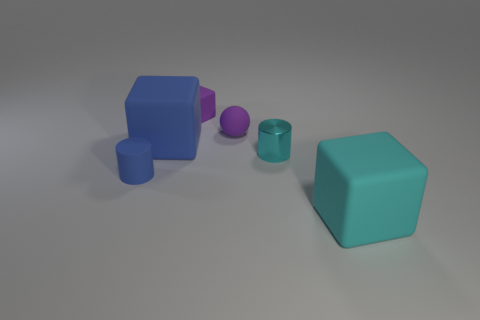There is a tiny matte thing that is the same shape as the big blue thing; what color is it?
Provide a short and direct response. Purple. Does the big matte cube in front of the tiny cyan thing have the same color as the small matte cylinder?
Offer a very short reply. No. How many small blue metal objects are there?
Keep it short and to the point. 0. Are the big block to the left of the cyan block and the purple sphere made of the same material?
Offer a terse response. Yes. Is there any other thing that has the same material as the cyan cylinder?
Make the answer very short. No. How many small blue cylinders are right of the cube that is in front of the small cylinder behind the tiny blue rubber thing?
Give a very brief answer. 0. The rubber cylinder has what size?
Provide a succinct answer. Small. Does the rubber ball have the same color as the tiny matte cube?
Give a very brief answer. Yes. There is a cylinder behind the tiny blue matte thing; how big is it?
Provide a succinct answer. Small. Do the large rubber block behind the large cyan rubber thing and the small cylinder that is left of the tiny purple block have the same color?
Your answer should be very brief. Yes. 